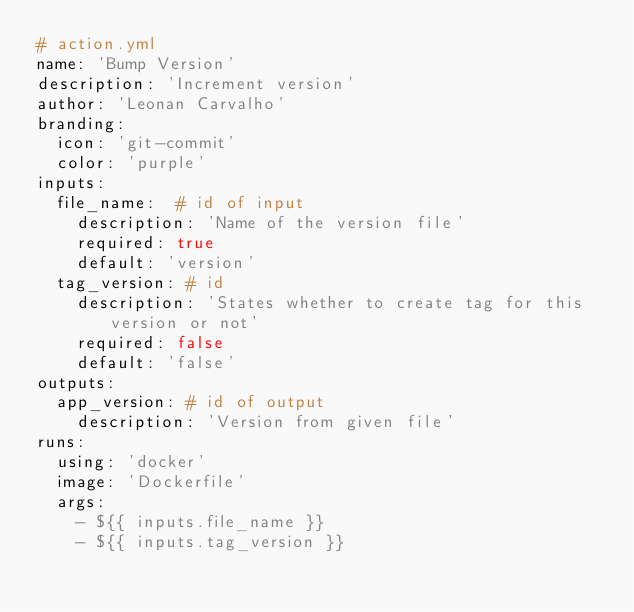Convert code to text. <code><loc_0><loc_0><loc_500><loc_500><_YAML_># action.yml
name: 'Bump Version'
description: 'Increment version'
author: 'Leonan Carvalho'
branding:
  icon: 'git-commit'
  color: 'purple'
inputs:
  file_name:  # id of input
    description: 'Name of the version file'
    required: true
    default: 'version'
  tag_version: # id
    description: 'States whether to create tag for this version or not'
    required: false
    default: 'false'
outputs:
  app_version: # id of output
    description: 'Version from given file'
runs:
  using: 'docker'
  image: 'Dockerfile'
  args:
    - ${{ inputs.file_name }} 
    - ${{ inputs.tag_version }}
</code> 